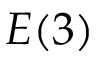<formula> <loc_0><loc_0><loc_500><loc_500>E ( 3 )</formula> 